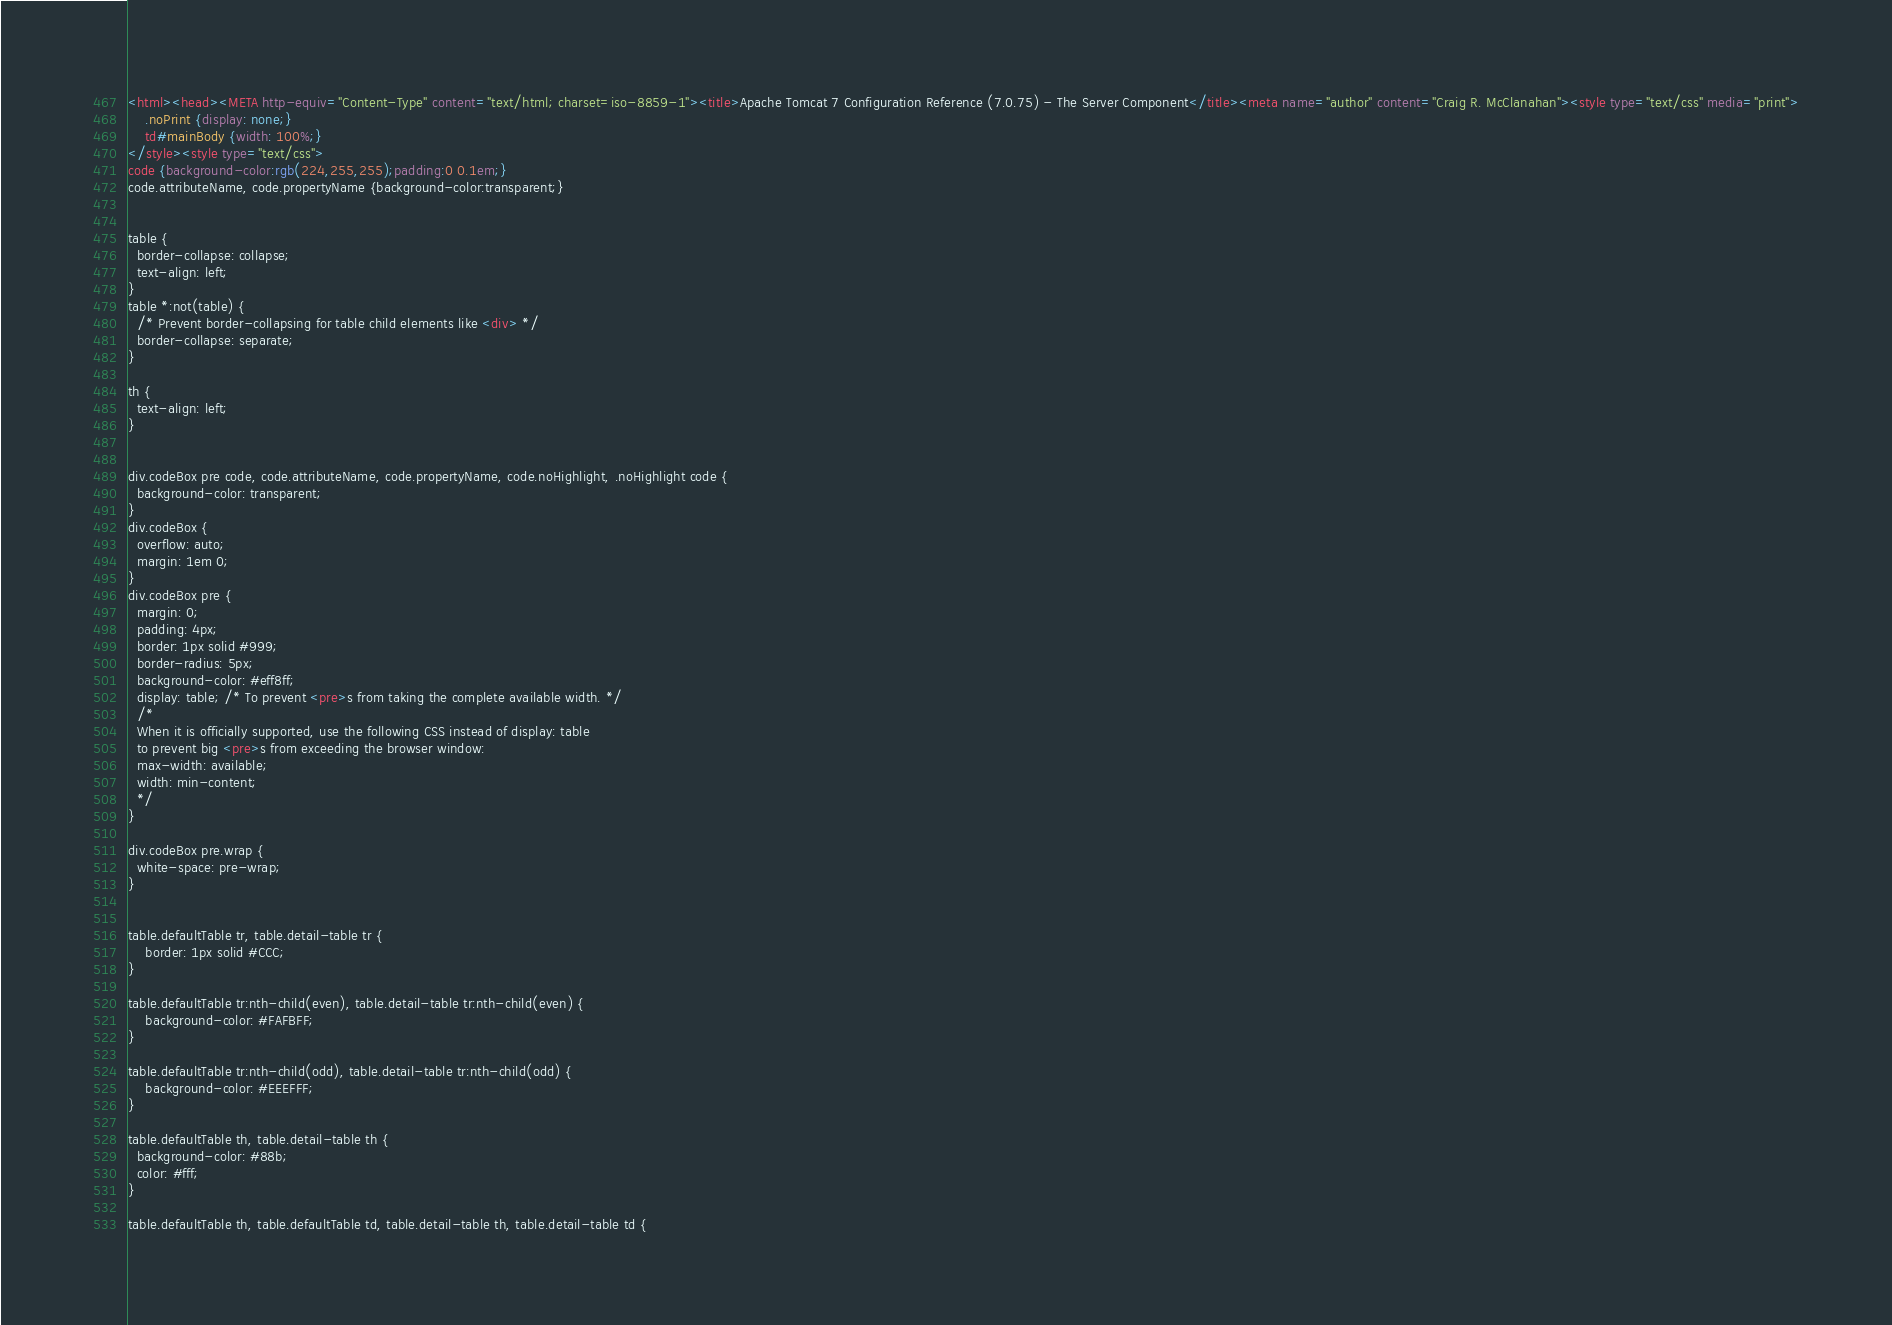<code> <loc_0><loc_0><loc_500><loc_500><_HTML_><html><head><META http-equiv="Content-Type" content="text/html; charset=iso-8859-1"><title>Apache Tomcat 7 Configuration Reference (7.0.75) - The Server Component</title><meta name="author" content="Craig R. McClanahan"><style type="text/css" media="print">
    .noPrint {display: none;}
    td#mainBody {width: 100%;}
</style><style type="text/css">
code {background-color:rgb(224,255,255);padding:0 0.1em;}
code.attributeName, code.propertyName {background-color:transparent;}


table {
  border-collapse: collapse;
  text-align: left;
}
table *:not(table) {
  /* Prevent border-collapsing for table child elements like <div> */
  border-collapse: separate;
}

th {
  text-align: left;
}


div.codeBox pre code, code.attributeName, code.propertyName, code.noHighlight, .noHighlight code {
  background-color: transparent;
}
div.codeBox {
  overflow: auto;
  margin: 1em 0;
}
div.codeBox pre {
  margin: 0;
  padding: 4px;
  border: 1px solid #999;
  border-radius: 5px;
  background-color: #eff8ff;
  display: table; /* To prevent <pre>s from taking the complete available width. */
  /*
  When it is officially supported, use the following CSS instead of display: table
  to prevent big <pre>s from exceeding the browser window:
  max-width: available;
  width: min-content;
  */
}

div.codeBox pre.wrap {
  white-space: pre-wrap;
}


table.defaultTable tr, table.detail-table tr {
    border: 1px solid #CCC;
}

table.defaultTable tr:nth-child(even), table.detail-table tr:nth-child(even) {
    background-color: #FAFBFF;
}

table.defaultTable tr:nth-child(odd), table.detail-table tr:nth-child(odd) {
    background-color: #EEEFFF;
}

table.defaultTable th, table.detail-table th {
  background-color: #88b;
  color: #fff;
}

table.defaultTable th, table.defaultTable td, table.detail-table th, table.detail-table td {</code> 